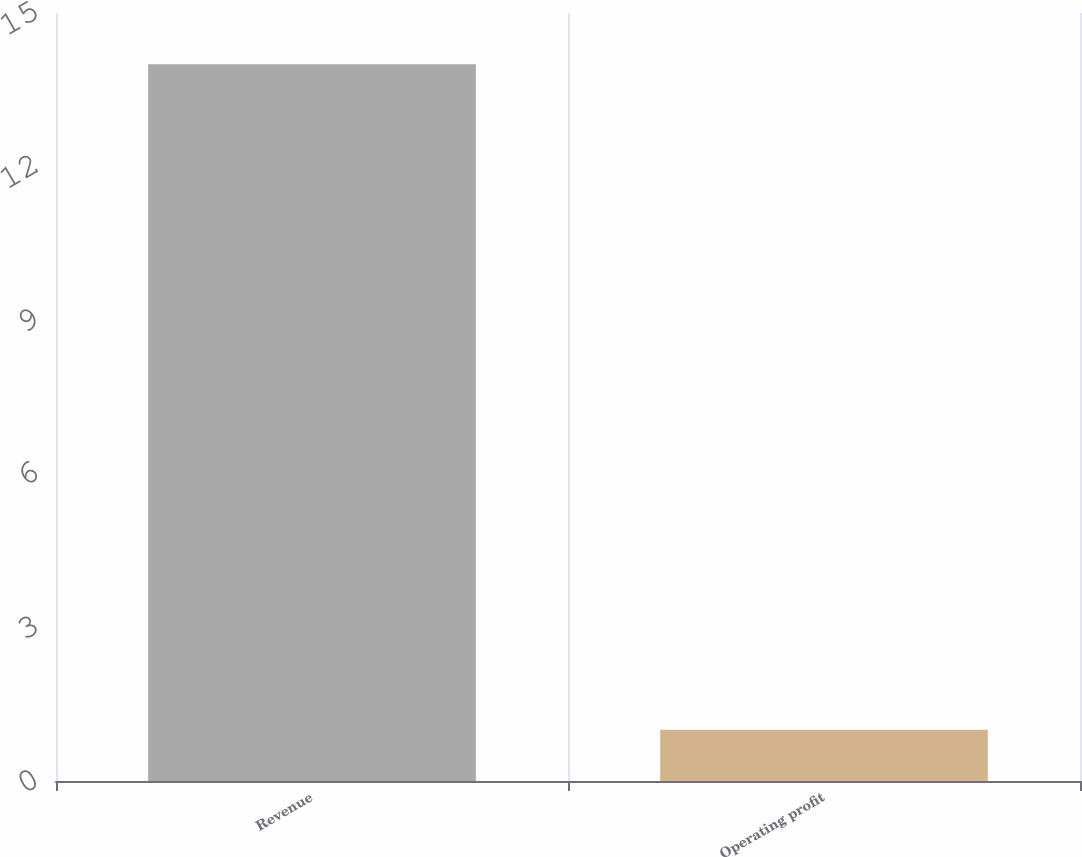Convert chart to OTSL. <chart><loc_0><loc_0><loc_500><loc_500><bar_chart><fcel>Revenue<fcel>Operating profit<nl><fcel>14<fcel>1<nl></chart> 